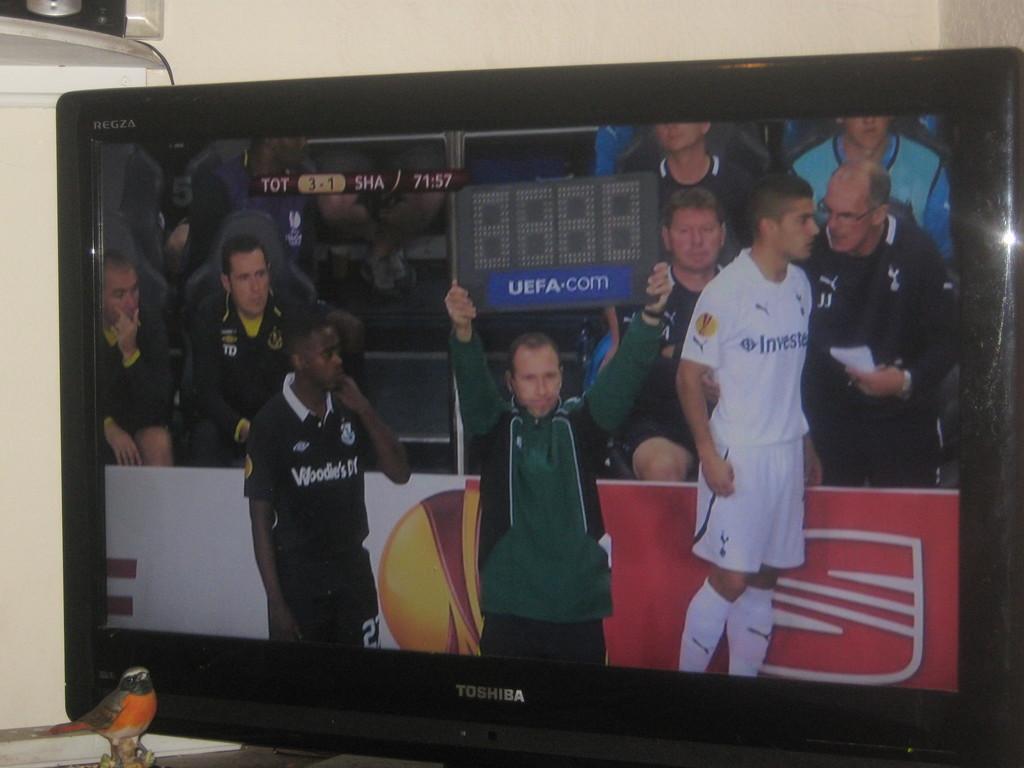Could you give a brief overview of what you see in this image? It's a video in the t. v. in the middle a person is standing. He wore a green color dress. In the right side another man is standing, he wore a white color dress. 